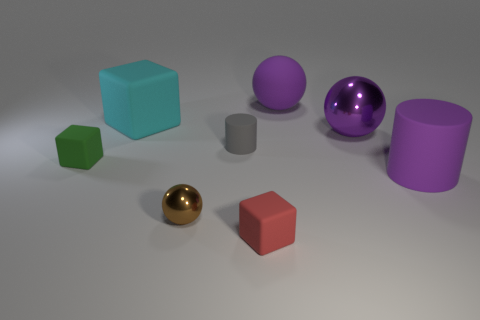Subtract 1 spheres. How many spheres are left? 2 Add 1 large gray metallic cylinders. How many objects exist? 9 Subtract all cylinders. How many objects are left? 6 Subtract 0 blue spheres. How many objects are left? 8 Subtract all tiny red cylinders. Subtract all small red matte things. How many objects are left? 7 Add 7 purple rubber things. How many purple rubber things are left? 9 Add 7 small cylinders. How many small cylinders exist? 8 